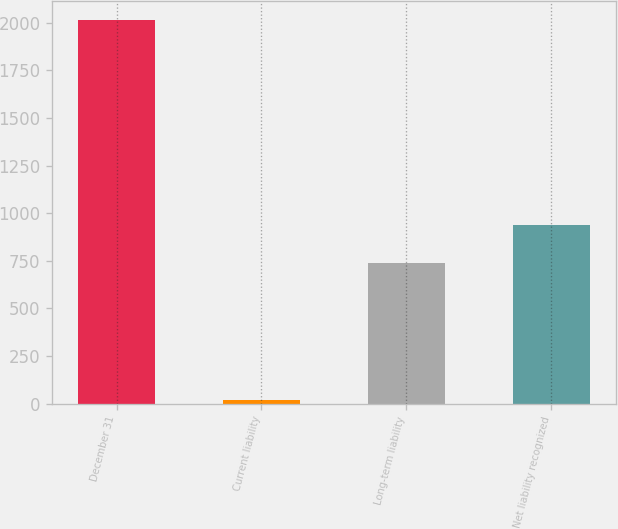<chart> <loc_0><loc_0><loc_500><loc_500><bar_chart><fcel>December 31<fcel>Current liability<fcel>Long-term liability<fcel>Net liability recognized<nl><fcel>2014<fcel>20<fcel>740<fcel>939.4<nl></chart> 